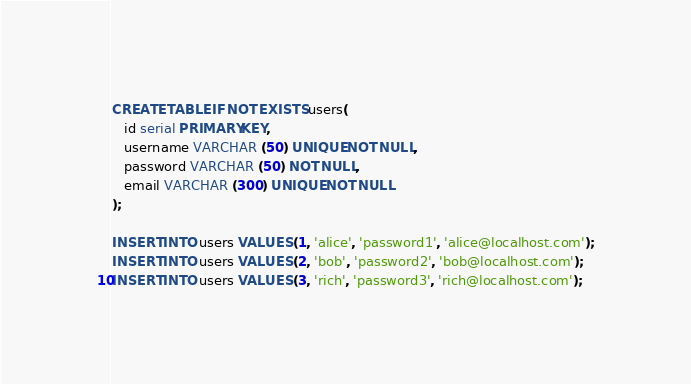Convert code to text. <code><loc_0><loc_0><loc_500><loc_500><_SQL_>CREATE TABLE IF NOT EXISTS users(
   id serial PRIMARY KEY,
   username VARCHAR (50) UNIQUE NOT NULL,
   password VARCHAR (50) NOT NULL,
   email VARCHAR (300) UNIQUE NOT NULL
);

INSERT INTO users VALUES (1, 'alice', 'password1', 'alice@localhost.com');
INSERT INTO users VALUES (2, 'bob', 'password2', 'bob@localhost.com');
INSERT INTO users VALUES (3, 'rich', 'password3', 'rich@localhost.com');
</code> 